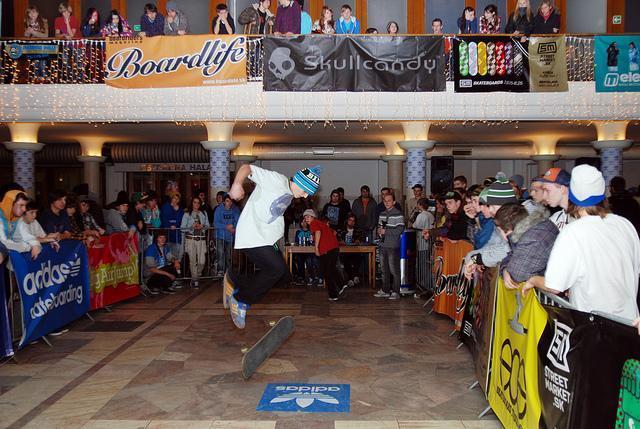How many people are there?
Give a very brief answer. 5. How many black dogs are on the bed?
Give a very brief answer. 0. 